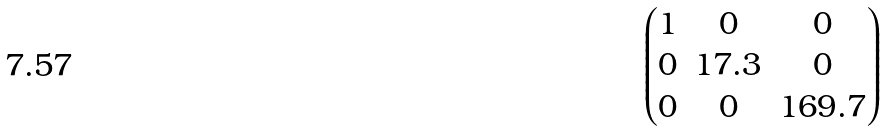<formula> <loc_0><loc_0><loc_500><loc_500>\begin{pmatrix} 1 & 0 & 0 \\ 0 & 1 7 . 3 & 0 \\ 0 & 0 & 1 6 9 . 7 \end{pmatrix}</formula> 